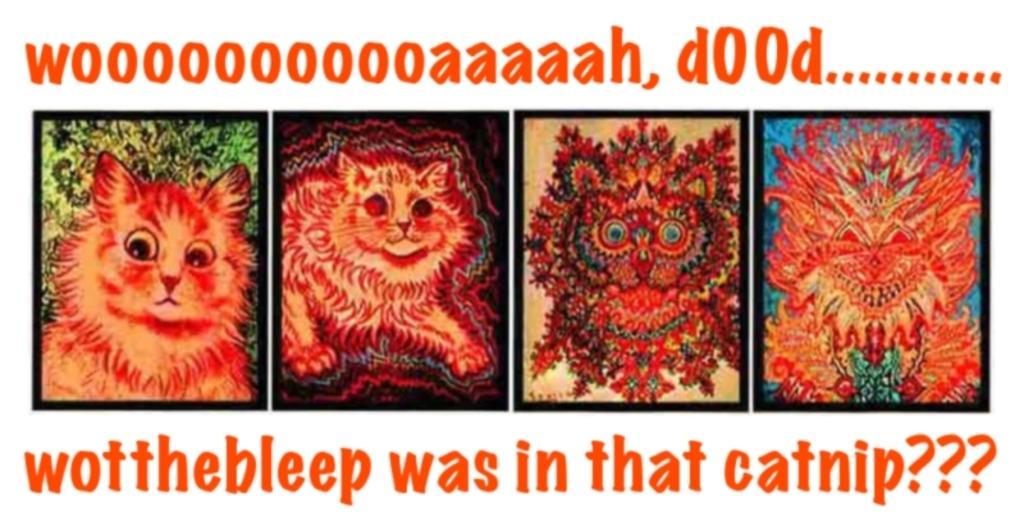Can you describe this image briefly? In this image I can see in the middle there are cartoon pictures, there is the text at the top and the bottom. 